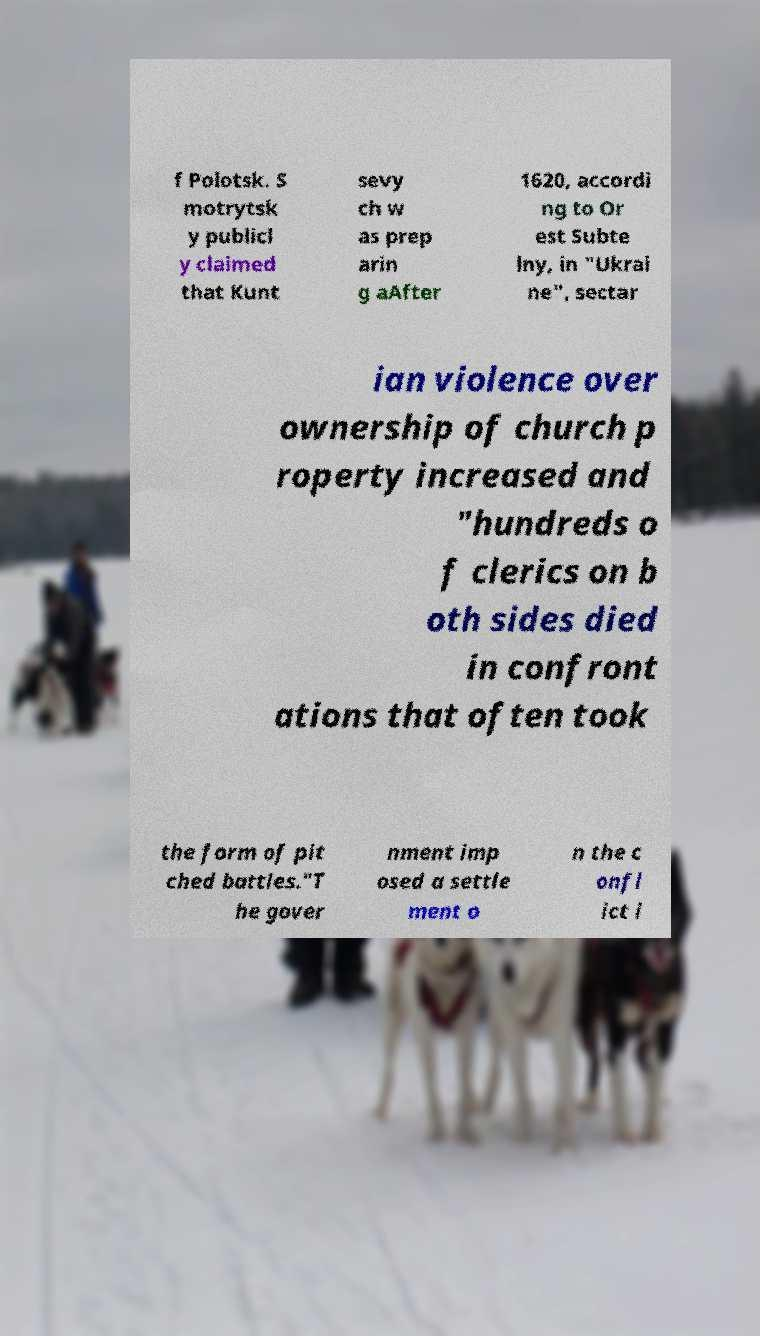Please read and relay the text visible in this image. What does it say? f Polotsk. S motrytsk y publicl y claimed that Kunt sevy ch w as prep arin g aAfter 1620, accordi ng to Or est Subte lny, in "Ukrai ne", sectar ian violence over ownership of church p roperty increased and "hundreds o f clerics on b oth sides died in confront ations that often took the form of pit ched battles."T he gover nment imp osed a settle ment o n the c onfl ict i 